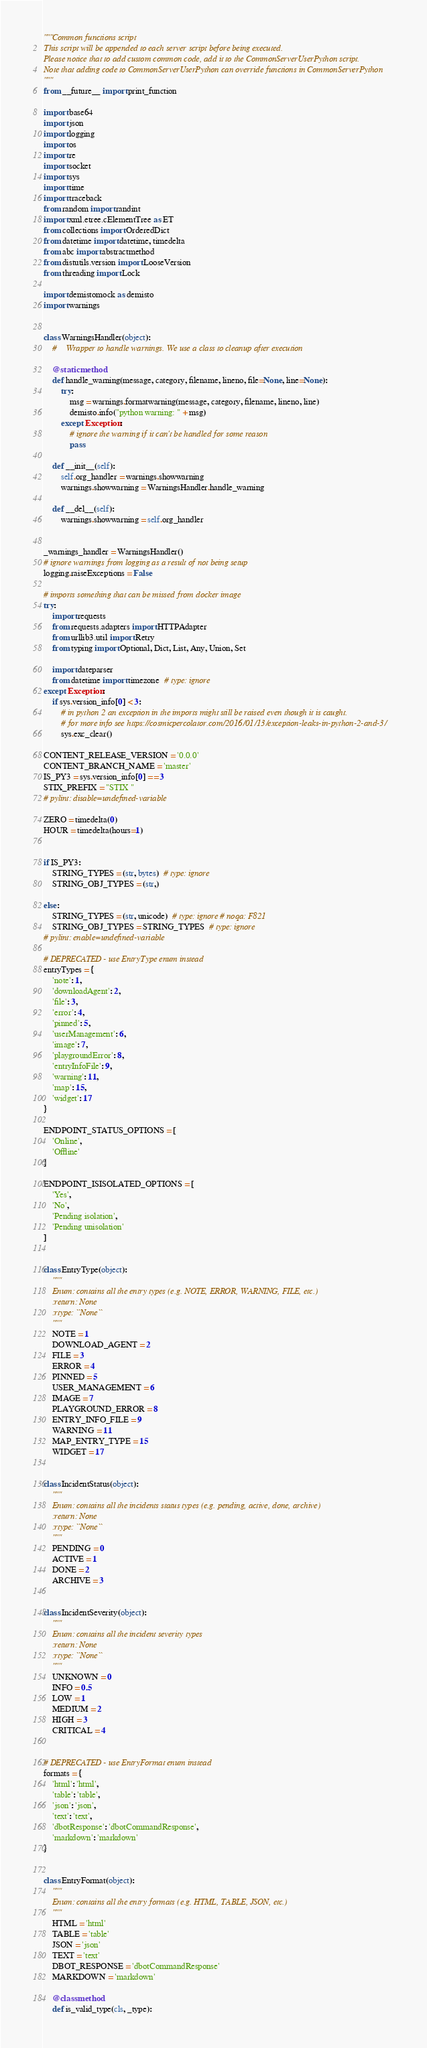Convert code to text. <code><loc_0><loc_0><loc_500><loc_500><_Python_>"""Common functions script
This script will be appended to each server script before being executed.
Please notice that to add custom common code, add it to the CommonServerUserPython script.
Note that adding code to CommonServerUserPython can override functions in CommonServerPython
"""
from __future__ import print_function

import base64
import json
import logging
import os
import re
import socket
import sys
import time
import traceback
from random import randint
import xml.etree.cElementTree as ET
from collections import OrderedDict
from datetime import datetime, timedelta
from abc import abstractmethod
from distutils.version import LooseVersion
from threading import Lock

import demistomock as demisto
import warnings


class WarningsHandler(object):
    #    Wrapper to handle warnings. We use a class to cleanup after execution

    @staticmethod
    def handle_warning(message, category, filename, lineno, file=None, line=None):
        try:
            msg = warnings.formatwarning(message, category, filename, lineno, line)
            demisto.info("python warning: " + msg)
        except Exception:
            # ignore the warning if it can't be handled for some reason
            pass

    def __init__(self):
        self.org_handler = warnings.showwarning
        warnings.showwarning = WarningsHandler.handle_warning

    def __del__(self):
        warnings.showwarning = self.org_handler


_warnings_handler = WarningsHandler()
# ignore warnings from logging as a result of not being setup
logging.raiseExceptions = False

# imports something that can be missed from docker image
try:
    import requests
    from requests.adapters import HTTPAdapter
    from urllib3.util import Retry
    from typing import Optional, Dict, List, Any, Union, Set

    import dateparser
    from datetime import timezone  # type: ignore
except Exception:
    if sys.version_info[0] < 3:
        # in python 2 an exception in the imports might still be raised even though it is caught.
        # for more info see https://cosmicpercolator.com/2016/01/13/exception-leaks-in-python-2-and-3/
        sys.exc_clear()

CONTENT_RELEASE_VERSION = '0.0.0'
CONTENT_BRANCH_NAME = 'master'
IS_PY3 = sys.version_info[0] == 3
STIX_PREFIX = "STIX "
# pylint: disable=undefined-variable

ZERO = timedelta(0)
HOUR = timedelta(hours=1)


if IS_PY3:
    STRING_TYPES = (str, bytes)  # type: ignore
    STRING_OBJ_TYPES = (str,)

else:
    STRING_TYPES = (str, unicode)  # type: ignore # noqa: F821
    STRING_OBJ_TYPES = STRING_TYPES  # type: ignore
# pylint: enable=undefined-variable

# DEPRECATED - use EntryType enum instead
entryTypes = {
    'note': 1,
    'downloadAgent': 2,
    'file': 3,
    'error': 4,
    'pinned': 5,
    'userManagement': 6,
    'image': 7,
    'playgroundError': 8,
    'entryInfoFile': 9,
    'warning': 11,
    'map': 15,
    'widget': 17
}

ENDPOINT_STATUS_OPTIONS = [
    'Online',
    'Offline'
]

ENDPOINT_ISISOLATED_OPTIONS = [
    'Yes',
    'No',
    'Pending isolation',
    'Pending unisolation'
]


class EntryType(object):
    """
    Enum: contains all the entry types (e.g. NOTE, ERROR, WARNING, FILE, etc.)
    :return: None
    :rtype: ``None``
    """
    NOTE = 1
    DOWNLOAD_AGENT = 2
    FILE = 3
    ERROR = 4
    PINNED = 5
    USER_MANAGEMENT = 6
    IMAGE = 7
    PLAYGROUND_ERROR = 8
    ENTRY_INFO_FILE = 9
    WARNING = 11
    MAP_ENTRY_TYPE = 15
    WIDGET = 17


class IncidentStatus(object):
    """
    Enum: contains all the incidents status types (e.g. pending, active, done, archive)
    :return: None
    :rtype: ``None``
    """
    PENDING = 0
    ACTIVE = 1
    DONE = 2
    ARCHIVE = 3


class IncidentSeverity(object):
    """
    Enum: contains all the incident severity types
    :return: None
    :rtype: ``None``
    """
    UNKNOWN = 0
    INFO = 0.5
    LOW = 1
    MEDIUM = 2
    HIGH = 3
    CRITICAL = 4


# DEPRECATED - use EntryFormat enum instead
formats = {
    'html': 'html',
    'table': 'table',
    'json': 'json',
    'text': 'text',
    'dbotResponse': 'dbotCommandResponse',
    'markdown': 'markdown'
}


class EntryFormat(object):
    """
    Enum: contains all the entry formats (e.g. HTML, TABLE, JSON, etc.)
    """
    HTML = 'html'
    TABLE = 'table'
    JSON = 'json'
    TEXT = 'text'
    DBOT_RESPONSE = 'dbotCommandResponse'
    MARKDOWN = 'markdown'

    @classmethod
    def is_valid_type(cls, _type):</code> 